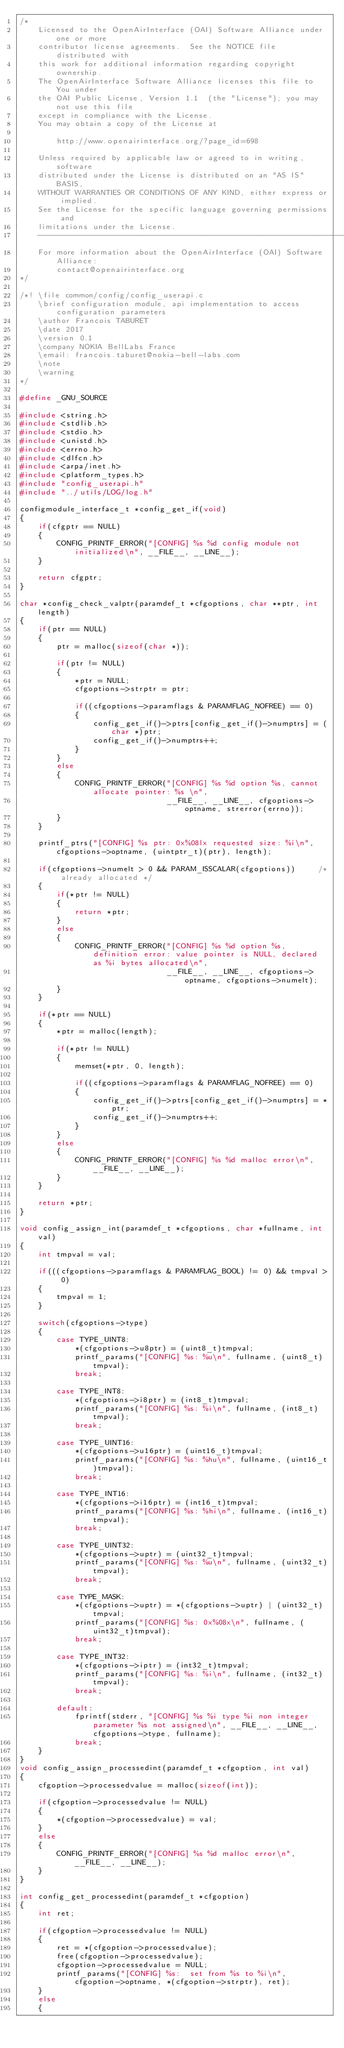Convert code to text. <code><loc_0><loc_0><loc_500><loc_500><_C_>/*
    Licensed to the OpenAirInterface (OAI) Software Alliance under one or more
    contributor license agreements.  See the NOTICE file distributed with
    this work for additional information regarding copyright ownership.
    The OpenAirInterface Software Alliance licenses this file to You under
    the OAI Public License, Version 1.1  (the "License"); you may not use this file
    except in compliance with the License.
    You may obtain a copy of the License at

        http://www.openairinterface.org/?page_id=698

    Unless required by applicable law or agreed to in writing, software
    distributed under the License is distributed on an "AS IS" BASIS,
    WITHOUT WARRANTIES OR CONDITIONS OF ANY KIND, either express or implied.
    See the License for the specific language governing permissions and
    limitations under the License.
    -------------------------------------------------------------------------------
    For more information about the OpenAirInterface (OAI) Software Alliance:
        contact@openairinterface.org
*/

/*! \file common/config/config_userapi.c
    \brief configuration module, api implementation to access configuration parameters
    \author Francois TABURET
    \date 2017
    \version 0.1
    \company NOKIA BellLabs France
    \email: francois.taburet@nokia-bell-labs.com
    \note
    \warning
*/

#define _GNU_SOURCE

#include <string.h>
#include <stdlib.h>
#include <stdio.h>
#include <unistd.h>
#include <errno.h>
#include <dlfcn.h>
#include <arpa/inet.h>
#include <platform_types.h>
#include "config_userapi.h"
#include "../utils/LOG/log.h"

configmodule_interface_t *config_get_if(void)
{
    if(cfgptr == NULL)
    {
        CONFIG_PRINTF_ERROR("[CONFIG] %s %d config module not initialized\n", __FILE__, __LINE__);
    }

    return cfgptr;
}

char *config_check_valptr(paramdef_t *cfgoptions, char **ptr, int length)
{
    if(ptr == NULL)
    {
        ptr = malloc(sizeof(char *));

        if(ptr != NULL)
        {
            *ptr = NULL;
            cfgoptions->strptr = ptr;

            if((cfgoptions->paramflags & PARAMFLAG_NOFREE) == 0)
            {
                config_get_if()->ptrs[config_get_if()->numptrs] = (char *)ptr;
                config_get_if()->numptrs++;
            }
        }
        else
        {
            CONFIG_PRINTF_ERROR("[CONFIG] %s %d option %s, cannot allocate pointer: %s \n",
                                __FILE__, __LINE__, cfgoptions->optname, strerror(errno));
        }
    }

    printf_ptrs("[CONFIG] %s ptr: 0x%08lx requested size: %i\n", cfgoptions->optname, (uintptr_t)(ptr), length);

    if(cfgoptions->numelt > 0 && PARAM_ISSCALAR(cfgoptions))     /* already allocated */
    {
        if(*ptr != NULL)
        {
            return *ptr;
        }
        else
        {
            CONFIG_PRINTF_ERROR("[CONFIG] %s %d option %s, definition error: value pointer is NULL, declared as %i bytes allocated\n",
                                __FILE__, __LINE__, cfgoptions->optname, cfgoptions->numelt);
        }
    }

    if(*ptr == NULL)
    {
        *ptr = malloc(length);

        if(*ptr != NULL)
        {
            memset(*ptr, 0, length);

            if((cfgoptions->paramflags & PARAMFLAG_NOFREE) == 0)
            {
                config_get_if()->ptrs[config_get_if()->numptrs] = *ptr;
                config_get_if()->numptrs++;
            }
        }
        else
        {
            CONFIG_PRINTF_ERROR("[CONFIG] %s %d malloc error\n", __FILE__, __LINE__);
        }
    }

    return *ptr;
}

void config_assign_int(paramdef_t *cfgoptions, char *fullname, int val)
{
    int tmpval = val;

    if(((cfgoptions->paramflags & PARAMFLAG_BOOL) != 0) && tmpval > 0)
    {
        tmpval = 1;
    }

    switch(cfgoptions->type)
    {
        case TYPE_UINT8:
            *(cfgoptions->u8ptr) = (uint8_t)tmpval;
            printf_params("[CONFIG] %s: %u\n", fullname, (uint8_t)tmpval);
            break;

        case TYPE_INT8:
            *(cfgoptions->i8ptr) = (int8_t)tmpval;
            printf_params("[CONFIG] %s: %i\n", fullname, (int8_t)tmpval);
            break;

        case TYPE_UINT16:
            *(cfgoptions->u16ptr) = (uint16_t)tmpval;
            printf_params("[CONFIG] %s: %hu\n", fullname, (uint16_t)tmpval);
            break;

        case TYPE_INT16:
            *(cfgoptions->i16ptr) = (int16_t)tmpval;
            printf_params("[CONFIG] %s: %hi\n", fullname, (int16_t)tmpval);
            break;

        case TYPE_UINT32:
            *(cfgoptions->uptr) = (uint32_t)tmpval;
            printf_params("[CONFIG] %s: %u\n", fullname, (uint32_t)tmpval);
            break;

        case TYPE_MASK:
            *(cfgoptions->uptr) = *(cfgoptions->uptr) | (uint32_t)tmpval;
            printf_params("[CONFIG] %s: 0x%08x\n", fullname, (uint32_t)tmpval);
            break;

        case TYPE_INT32:
            *(cfgoptions->iptr) = (int32_t)tmpval;
            printf_params("[CONFIG] %s: %i\n", fullname, (int32_t)tmpval);
            break;

        default:
            fprintf(stderr, "[CONFIG] %s %i type %i non integer parameter %s not assigned\n", __FILE__, __LINE__, cfgoptions->type, fullname);
            break;
    }
}
void config_assign_processedint(paramdef_t *cfgoption, int val)
{
    cfgoption->processedvalue = malloc(sizeof(int));

    if(cfgoption->processedvalue != NULL)
    {
        *(cfgoption->processedvalue) = val;
    }
    else
    {
        CONFIG_PRINTF_ERROR("[CONFIG] %s %d malloc error\n", __FILE__, __LINE__);
    }
}

int config_get_processedint(paramdef_t *cfgoption)
{
    int ret;

    if(cfgoption->processedvalue != NULL)
    {
        ret = *(cfgoption->processedvalue);
        free(cfgoption->processedvalue);
        cfgoption->processedvalue = NULL;
        printf_params("[CONFIG] %s:  set from %s to %i\n", cfgoption->optname, *(cfgoption->strptr), ret);
    }
    else
    {</code> 